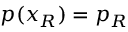<formula> <loc_0><loc_0><loc_500><loc_500>p ( x _ { R } ) = p _ { R }</formula> 